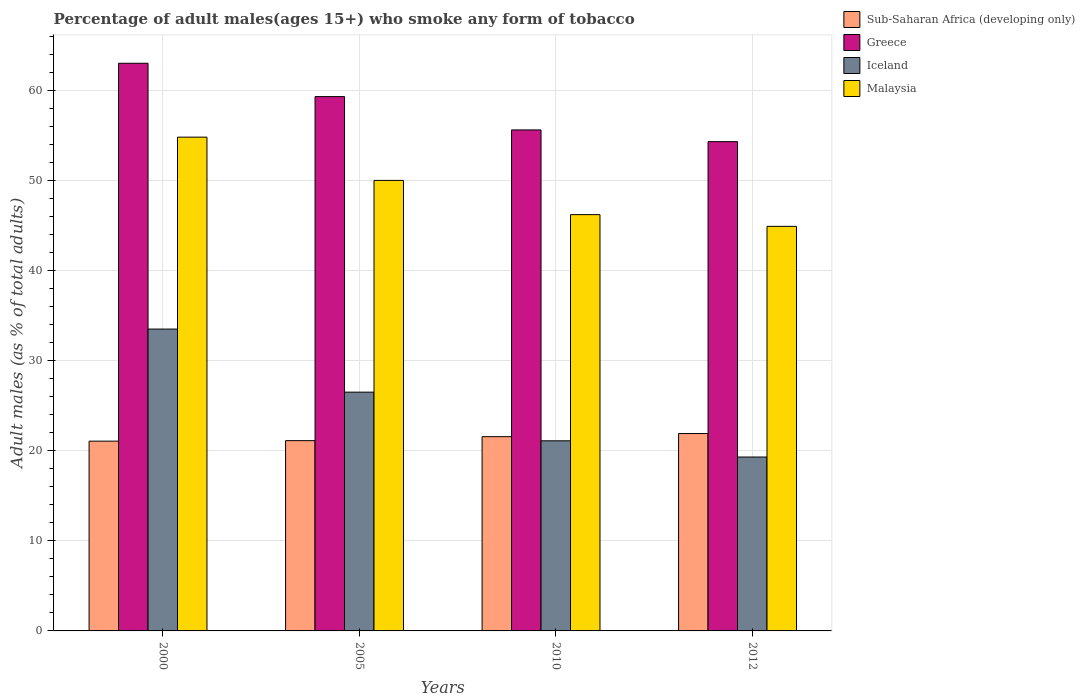How many different coloured bars are there?
Offer a very short reply. 4. How many groups of bars are there?
Keep it short and to the point. 4. What is the label of the 4th group of bars from the left?
Provide a succinct answer. 2012. What is the percentage of adult males who smoke in Malaysia in 2012?
Keep it short and to the point. 44.9. Across all years, what is the maximum percentage of adult males who smoke in Sub-Saharan Africa (developing only)?
Keep it short and to the point. 21.91. Across all years, what is the minimum percentage of adult males who smoke in Malaysia?
Make the answer very short. 44.9. What is the total percentage of adult males who smoke in Greece in the graph?
Keep it short and to the point. 232.2. What is the difference between the percentage of adult males who smoke in Iceland in 2010 and the percentage of adult males who smoke in Greece in 2012?
Provide a succinct answer. -33.2. What is the average percentage of adult males who smoke in Sub-Saharan Africa (developing only) per year?
Provide a succinct answer. 21.41. In the year 2000, what is the difference between the percentage of adult males who smoke in Sub-Saharan Africa (developing only) and percentage of adult males who smoke in Iceland?
Your answer should be very brief. -12.44. In how many years, is the percentage of adult males who smoke in Malaysia greater than 34 %?
Make the answer very short. 4. What is the ratio of the percentage of adult males who smoke in Iceland in 2010 to that in 2012?
Provide a short and direct response. 1.09. Is the percentage of adult males who smoke in Sub-Saharan Africa (developing only) in 2005 less than that in 2010?
Offer a terse response. Yes. What is the difference between the highest and the second highest percentage of adult males who smoke in Sub-Saharan Africa (developing only)?
Give a very brief answer. 0.35. What is the difference between the highest and the lowest percentage of adult males who smoke in Sub-Saharan Africa (developing only)?
Offer a terse response. 0.85. Is it the case that in every year, the sum of the percentage of adult males who smoke in Iceland and percentage of adult males who smoke in Malaysia is greater than the sum of percentage of adult males who smoke in Sub-Saharan Africa (developing only) and percentage of adult males who smoke in Greece?
Keep it short and to the point. Yes. What does the 3rd bar from the left in 2012 represents?
Provide a succinct answer. Iceland. What does the 4th bar from the right in 2010 represents?
Offer a terse response. Sub-Saharan Africa (developing only). How many years are there in the graph?
Your response must be concise. 4. What is the difference between two consecutive major ticks on the Y-axis?
Give a very brief answer. 10. Are the values on the major ticks of Y-axis written in scientific E-notation?
Your answer should be very brief. No. How many legend labels are there?
Provide a short and direct response. 4. What is the title of the graph?
Offer a terse response. Percentage of adult males(ages 15+) who smoke any form of tobacco. Does "Lithuania" appear as one of the legend labels in the graph?
Make the answer very short. No. What is the label or title of the X-axis?
Your response must be concise. Years. What is the label or title of the Y-axis?
Give a very brief answer. Adult males (as % of total adults). What is the Adult males (as % of total adults) in Sub-Saharan Africa (developing only) in 2000?
Ensure brevity in your answer.  21.06. What is the Adult males (as % of total adults) in Iceland in 2000?
Provide a succinct answer. 33.5. What is the Adult males (as % of total adults) of Malaysia in 2000?
Offer a terse response. 54.8. What is the Adult males (as % of total adults) of Sub-Saharan Africa (developing only) in 2005?
Offer a very short reply. 21.12. What is the Adult males (as % of total adults) in Greece in 2005?
Offer a terse response. 59.3. What is the Adult males (as % of total adults) in Iceland in 2005?
Provide a succinct answer. 26.5. What is the Adult males (as % of total adults) in Sub-Saharan Africa (developing only) in 2010?
Your answer should be very brief. 21.56. What is the Adult males (as % of total adults) of Greece in 2010?
Your response must be concise. 55.6. What is the Adult males (as % of total adults) in Iceland in 2010?
Offer a very short reply. 21.1. What is the Adult males (as % of total adults) in Malaysia in 2010?
Your response must be concise. 46.2. What is the Adult males (as % of total adults) of Sub-Saharan Africa (developing only) in 2012?
Your answer should be very brief. 21.91. What is the Adult males (as % of total adults) of Greece in 2012?
Keep it short and to the point. 54.3. What is the Adult males (as % of total adults) in Iceland in 2012?
Offer a terse response. 19.3. What is the Adult males (as % of total adults) in Malaysia in 2012?
Keep it short and to the point. 44.9. Across all years, what is the maximum Adult males (as % of total adults) in Sub-Saharan Africa (developing only)?
Your answer should be compact. 21.91. Across all years, what is the maximum Adult males (as % of total adults) in Greece?
Your answer should be compact. 63. Across all years, what is the maximum Adult males (as % of total adults) of Iceland?
Make the answer very short. 33.5. Across all years, what is the maximum Adult males (as % of total adults) of Malaysia?
Offer a very short reply. 54.8. Across all years, what is the minimum Adult males (as % of total adults) in Sub-Saharan Africa (developing only)?
Your response must be concise. 21.06. Across all years, what is the minimum Adult males (as % of total adults) of Greece?
Offer a terse response. 54.3. Across all years, what is the minimum Adult males (as % of total adults) in Iceland?
Your answer should be very brief. 19.3. Across all years, what is the minimum Adult males (as % of total adults) of Malaysia?
Your answer should be compact. 44.9. What is the total Adult males (as % of total adults) of Sub-Saharan Africa (developing only) in the graph?
Give a very brief answer. 85.64. What is the total Adult males (as % of total adults) of Greece in the graph?
Offer a terse response. 232.2. What is the total Adult males (as % of total adults) of Iceland in the graph?
Offer a terse response. 100.4. What is the total Adult males (as % of total adults) in Malaysia in the graph?
Make the answer very short. 195.9. What is the difference between the Adult males (as % of total adults) in Sub-Saharan Africa (developing only) in 2000 and that in 2005?
Your answer should be very brief. -0.06. What is the difference between the Adult males (as % of total adults) in Greece in 2000 and that in 2005?
Provide a short and direct response. 3.7. What is the difference between the Adult males (as % of total adults) of Iceland in 2000 and that in 2005?
Offer a terse response. 7. What is the difference between the Adult males (as % of total adults) in Malaysia in 2000 and that in 2005?
Your answer should be compact. 4.8. What is the difference between the Adult males (as % of total adults) in Sub-Saharan Africa (developing only) in 2000 and that in 2010?
Ensure brevity in your answer.  -0.5. What is the difference between the Adult males (as % of total adults) of Malaysia in 2000 and that in 2010?
Keep it short and to the point. 8.6. What is the difference between the Adult males (as % of total adults) in Sub-Saharan Africa (developing only) in 2000 and that in 2012?
Your response must be concise. -0.85. What is the difference between the Adult males (as % of total adults) in Iceland in 2000 and that in 2012?
Make the answer very short. 14.2. What is the difference between the Adult males (as % of total adults) of Malaysia in 2000 and that in 2012?
Provide a short and direct response. 9.9. What is the difference between the Adult males (as % of total adults) in Sub-Saharan Africa (developing only) in 2005 and that in 2010?
Provide a short and direct response. -0.44. What is the difference between the Adult males (as % of total adults) in Iceland in 2005 and that in 2010?
Provide a succinct answer. 5.4. What is the difference between the Adult males (as % of total adults) in Malaysia in 2005 and that in 2010?
Keep it short and to the point. 3.8. What is the difference between the Adult males (as % of total adults) of Sub-Saharan Africa (developing only) in 2005 and that in 2012?
Provide a short and direct response. -0.79. What is the difference between the Adult males (as % of total adults) in Iceland in 2005 and that in 2012?
Provide a succinct answer. 7.2. What is the difference between the Adult males (as % of total adults) in Sub-Saharan Africa (developing only) in 2010 and that in 2012?
Offer a terse response. -0.35. What is the difference between the Adult males (as % of total adults) of Iceland in 2010 and that in 2012?
Make the answer very short. 1.8. What is the difference between the Adult males (as % of total adults) of Malaysia in 2010 and that in 2012?
Provide a short and direct response. 1.3. What is the difference between the Adult males (as % of total adults) in Sub-Saharan Africa (developing only) in 2000 and the Adult males (as % of total adults) in Greece in 2005?
Provide a succinct answer. -38.24. What is the difference between the Adult males (as % of total adults) of Sub-Saharan Africa (developing only) in 2000 and the Adult males (as % of total adults) of Iceland in 2005?
Keep it short and to the point. -5.44. What is the difference between the Adult males (as % of total adults) of Sub-Saharan Africa (developing only) in 2000 and the Adult males (as % of total adults) of Malaysia in 2005?
Make the answer very short. -28.94. What is the difference between the Adult males (as % of total adults) in Greece in 2000 and the Adult males (as % of total adults) in Iceland in 2005?
Your response must be concise. 36.5. What is the difference between the Adult males (as % of total adults) in Iceland in 2000 and the Adult males (as % of total adults) in Malaysia in 2005?
Your answer should be very brief. -16.5. What is the difference between the Adult males (as % of total adults) in Sub-Saharan Africa (developing only) in 2000 and the Adult males (as % of total adults) in Greece in 2010?
Offer a very short reply. -34.54. What is the difference between the Adult males (as % of total adults) in Sub-Saharan Africa (developing only) in 2000 and the Adult males (as % of total adults) in Iceland in 2010?
Offer a very short reply. -0.04. What is the difference between the Adult males (as % of total adults) in Sub-Saharan Africa (developing only) in 2000 and the Adult males (as % of total adults) in Malaysia in 2010?
Give a very brief answer. -25.14. What is the difference between the Adult males (as % of total adults) in Greece in 2000 and the Adult males (as % of total adults) in Iceland in 2010?
Offer a terse response. 41.9. What is the difference between the Adult males (as % of total adults) of Greece in 2000 and the Adult males (as % of total adults) of Malaysia in 2010?
Provide a succinct answer. 16.8. What is the difference between the Adult males (as % of total adults) in Iceland in 2000 and the Adult males (as % of total adults) in Malaysia in 2010?
Provide a short and direct response. -12.7. What is the difference between the Adult males (as % of total adults) in Sub-Saharan Africa (developing only) in 2000 and the Adult males (as % of total adults) in Greece in 2012?
Give a very brief answer. -33.24. What is the difference between the Adult males (as % of total adults) in Sub-Saharan Africa (developing only) in 2000 and the Adult males (as % of total adults) in Iceland in 2012?
Your response must be concise. 1.76. What is the difference between the Adult males (as % of total adults) of Sub-Saharan Africa (developing only) in 2000 and the Adult males (as % of total adults) of Malaysia in 2012?
Provide a short and direct response. -23.84. What is the difference between the Adult males (as % of total adults) in Greece in 2000 and the Adult males (as % of total adults) in Iceland in 2012?
Your response must be concise. 43.7. What is the difference between the Adult males (as % of total adults) in Sub-Saharan Africa (developing only) in 2005 and the Adult males (as % of total adults) in Greece in 2010?
Provide a short and direct response. -34.48. What is the difference between the Adult males (as % of total adults) in Sub-Saharan Africa (developing only) in 2005 and the Adult males (as % of total adults) in Iceland in 2010?
Give a very brief answer. 0.02. What is the difference between the Adult males (as % of total adults) in Sub-Saharan Africa (developing only) in 2005 and the Adult males (as % of total adults) in Malaysia in 2010?
Your response must be concise. -25.08. What is the difference between the Adult males (as % of total adults) in Greece in 2005 and the Adult males (as % of total adults) in Iceland in 2010?
Give a very brief answer. 38.2. What is the difference between the Adult males (as % of total adults) in Greece in 2005 and the Adult males (as % of total adults) in Malaysia in 2010?
Your answer should be compact. 13.1. What is the difference between the Adult males (as % of total adults) in Iceland in 2005 and the Adult males (as % of total adults) in Malaysia in 2010?
Your response must be concise. -19.7. What is the difference between the Adult males (as % of total adults) of Sub-Saharan Africa (developing only) in 2005 and the Adult males (as % of total adults) of Greece in 2012?
Give a very brief answer. -33.18. What is the difference between the Adult males (as % of total adults) of Sub-Saharan Africa (developing only) in 2005 and the Adult males (as % of total adults) of Iceland in 2012?
Make the answer very short. 1.82. What is the difference between the Adult males (as % of total adults) in Sub-Saharan Africa (developing only) in 2005 and the Adult males (as % of total adults) in Malaysia in 2012?
Provide a short and direct response. -23.78. What is the difference between the Adult males (as % of total adults) in Greece in 2005 and the Adult males (as % of total adults) in Malaysia in 2012?
Provide a succinct answer. 14.4. What is the difference between the Adult males (as % of total adults) of Iceland in 2005 and the Adult males (as % of total adults) of Malaysia in 2012?
Provide a short and direct response. -18.4. What is the difference between the Adult males (as % of total adults) in Sub-Saharan Africa (developing only) in 2010 and the Adult males (as % of total adults) in Greece in 2012?
Make the answer very short. -32.74. What is the difference between the Adult males (as % of total adults) of Sub-Saharan Africa (developing only) in 2010 and the Adult males (as % of total adults) of Iceland in 2012?
Offer a very short reply. 2.26. What is the difference between the Adult males (as % of total adults) in Sub-Saharan Africa (developing only) in 2010 and the Adult males (as % of total adults) in Malaysia in 2012?
Provide a succinct answer. -23.34. What is the difference between the Adult males (as % of total adults) of Greece in 2010 and the Adult males (as % of total adults) of Iceland in 2012?
Provide a succinct answer. 36.3. What is the difference between the Adult males (as % of total adults) in Iceland in 2010 and the Adult males (as % of total adults) in Malaysia in 2012?
Give a very brief answer. -23.8. What is the average Adult males (as % of total adults) of Sub-Saharan Africa (developing only) per year?
Make the answer very short. 21.41. What is the average Adult males (as % of total adults) of Greece per year?
Your response must be concise. 58.05. What is the average Adult males (as % of total adults) in Iceland per year?
Ensure brevity in your answer.  25.1. What is the average Adult males (as % of total adults) in Malaysia per year?
Give a very brief answer. 48.98. In the year 2000, what is the difference between the Adult males (as % of total adults) of Sub-Saharan Africa (developing only) and Adult males (as % of total adults) of Greece?
Make the answer very short. -41.94. In the year 2000, what is the difference between the Adult males (as % of total adults) in Sub-Saharan Africa (developing only) and Adult males (as % of total adults) in Iceland?
Provide a succinct answer. -12.44. In the year 2000, what is the difference between the Adult males (as % of total adults) of Sub-Saharan Africa (developing only) and Adult males (as % of total adults) of Malaysia?
Keep it short and to the point. -33.74. In the year 2000, what is the difference between the Adult males (as % of total adults) in Greece and Adult males (as % of total adults) in Iceland?
Offer a very short reply. 29.5. In the year 2000, what is the difference between the Adult males (as % of total adults) in Iceland and Adult males (as % of total adults) in Malaysia?
Offer a very short reply. -21.3. In the year 2005, what is the difference between the Adult males (as % of total adults) of Sub-Saharan Africa (developing only) and Adult males (as % of total adults) of Greece?
Your answer should be very brief. -38.18. In the year 2005, what is the difference between the Adult males (as % of total adults) of Sub-Saharan Africa (developing only) and Adult males (as % of total adults) of Iceland?
Your answer should be very brief. -5.38. In the year 2005, what is the difference between the Adult males (as % of total adults) in Sub-Saharan Africa (developing only) and Adult males (as % of total adults) in Malaysia?
Provide a short and direct response. -28.88. In the year 2005, what is the difference between the Adult males (as % of total adults) of Greece and Adult males (as % of total adults) of Iceland?
Your answer should be very brief. 32.8. In the year 2005, what is the difference between the Adult males (as % of total adults) in Iceland and Adult males (as % of total adults) in Malaysia?
Your response must be concise. -23.5. In the year 2010, what is the difference between the Adult males (as % of total adults) of Sub-Saharan Africa (developing only) and Adult males (as % of total adults) of Greece?
Make the answer very short. -34.04. In the year 2010, what is the difference between the Adult males (as % of total adults) in Sub-Saharan Africa (developing only) and Adult males (as % of total adults) in Iceland?
Ensure brevity in your answer.  0.46. In the year 2010, what is the difference between the Adult males (as % of total adults) in Sub-Saharan Africa (developing only) and Adult males (as % of total adults) in Malaysia?
Give a very brief answer. -24.64. In the year 2010, what is the difference between the Adult males (as % of total adults) of Greece and Adult males (as % of total adults) of Iceland?
Keep it short and to the point. 34.5. In the year 2010, what is the difference between the Adult males (as % of total adults) of Iceland and Adult males (as % of total adults) of Malaysia?
Make the answer very short. -25.1. In the year 2012, what is the difference between the Adult males (as % of total adults) of Sub-Saharan Africa (developing only) and Adult males (as % of total adults) of Greece?
Your answer should be very brief. -32.39. In the year 2012, what is the difference between the Adult males (as % of total adults) in Sub-Saharan Africa (developing only) and Adult males (as % of total adults) in Iceland?
Your answer should be compact. 2.61. In the year 2012, what is the difference between the Adult males (as % of total adults) in Sub-Saharan Africa (developing only) and Adult males (as % of total adults) in Malaysia?
Make the answer very short. -22.99. In the year 2012, what is the difference between the Adult males (as % of total adults) in Greece and Adult males (as % of total adults) in Malaysia?
Keep it short and to the point. 9.4. In the year 2012, what is the difference between the Adult males (as % of total adults) of Iceland and Adult males (as % of total adults) of Malaysia?
Your answer should be compact. -25.6. What is the ratio of the Adult males (as % of total adults) in Sub-Saharan Africa (developing only) in 2000 to that in 2005?
Provide a short and direct response. 1. What is the ratio of the Adult males (as % of total adults) in Greece in 2000 to that in 2005?
Offer a very short reply. 1.06. What is the ratio of the Adult males (as % of total adults) in Iceland in 2000 to that in 2005?
Provide a short and direct response. 1.26. What is the ratio of the Adult males (as % of total adults) of Malaysia in 2000 to that in 2005?
Your answer should be compact. 1.1. What is the ratio of the Adult males (as % of total adults) of Sub-Saharan Africa (developing only) in 2000 to that in 2010?
Your answer should be very brief. 0.98. What is the ratio of the Adult males (as % of total adults) in Greece in 2000 to that in 2010?
Your answer should be compact. 1.13. What is the ratio of the Adult males (as % of total adults) of Iceland in 2000 to that in 2010?
Offer a very short reply. 1.59. What is the ratio of the Adult males (as % of total adults) in Malaysia in 2000 to that in 2010?
Offer a terse response. 1.19. What is the ratio of the Adult males (as % of total adults) of Sub-Saharan Africa (developing only) in 2000 to that in 2012?
Give a very brief answer. 0.96. What is the ratio of the Adult males (as % of total adults) of Greece in 2000 to that in 2012?
Offer a terse response. 1.16. What is the ratio of the Adult males (as % of total adults) of Iceland in 2000 to that in 2012?
Your response must be concise. 1.74. What is the ratio of the Adult males (as % of total adults) of Malaysia in 2000 to that in 2012?
Your answer should be compact. 1.22. What is the ratio of the Adult males (as % of total adults) of Sub-Saharan Africa (developing only) in 2005 to that in 2010?
Provide a succinct answer. 0.98. What is the ratio of the Adult males (as % of total adults) of Greece in 2005 to that in 2010?
Your response must be concise. 1.07. What is the ratio of the Adult males (as % of total adults) of Iceland in 2005 to that in 2010?
Make the answer very short. 1.26. What is the ratio of the Adult males (as % of total adults) in Malaysia in 2005 to that in 2010?
Offer a terse response. 1.08. What is the ratio of the Adult males (as % of total adults) of Sub-Saharan Africa (developing only) in 2005 to that in 2012?
Make the answer very short. 0.96. What is the ratio of the Adult males (as % of total adults) in Greece in 2005 to that in 2012?
Offer a terse response. 1.09. What is the ratio of the Adult males (as % of total adults) in Iceland in 2005 to that in 2012?
Your answer should be compact. 1.37. What is the ratio of the Adult males (as % of total adults) in Malaysia in 2005 to that in 2012?
Your response must be concise. 1.11. What is the ratio of the Adult males (as % of total adults) of Sub-Saharan Africa (developing only) in 2010 to that in 2012?
Offer a very short reply. 0.98. What is the ratio of the Adult males (as % of total adults) of Greece in 2010 to that in 2012?
Give a very brief answer. 1.02. What is the ratio of the Adult males (as % of total adults) of Iceland in 2010 to that in 2012?
Keep it short and to the point. 1.09. What is the difference between the highest and the second highest Adult males (as % of total adults) of Sub-Saharan Africa (developing only)?
Offer a terse response. 0.35. What is the difference between the highest and the second highest Adult males (as % of total adults) of Greece?
Offer a terse response. 3.7. What is the difference between the highest and the lowest Adult males (as % of total adults) in Sub-Saharan Africa (developing only)?
Offer a terse response. 0.85. What is the difference between the highest and the lowest Adult males (as % of total adults) in Greece?
Your response must be concise. 8.7. What is the difference between the highest and the lowest Adult males (as % of total adults) in Iceland?
Provide a succinct answer. 14.2. What is the difference between the highest and the lowest Adult males (as % of total adults) in Malaysia?
Offer a very short reply. 9.9. 